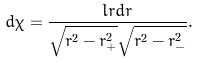Convert formula to latex. <formula><loc_0><loc_0><loc_500><loc_500>d \chi = \frac { l r d r } { \sqrt { r ^ { 2 } - r ^ { 2 } _ { + } } \sqrt { r ^ { 2 } - r ^ { 2 } _ { - } } } .</formula> 